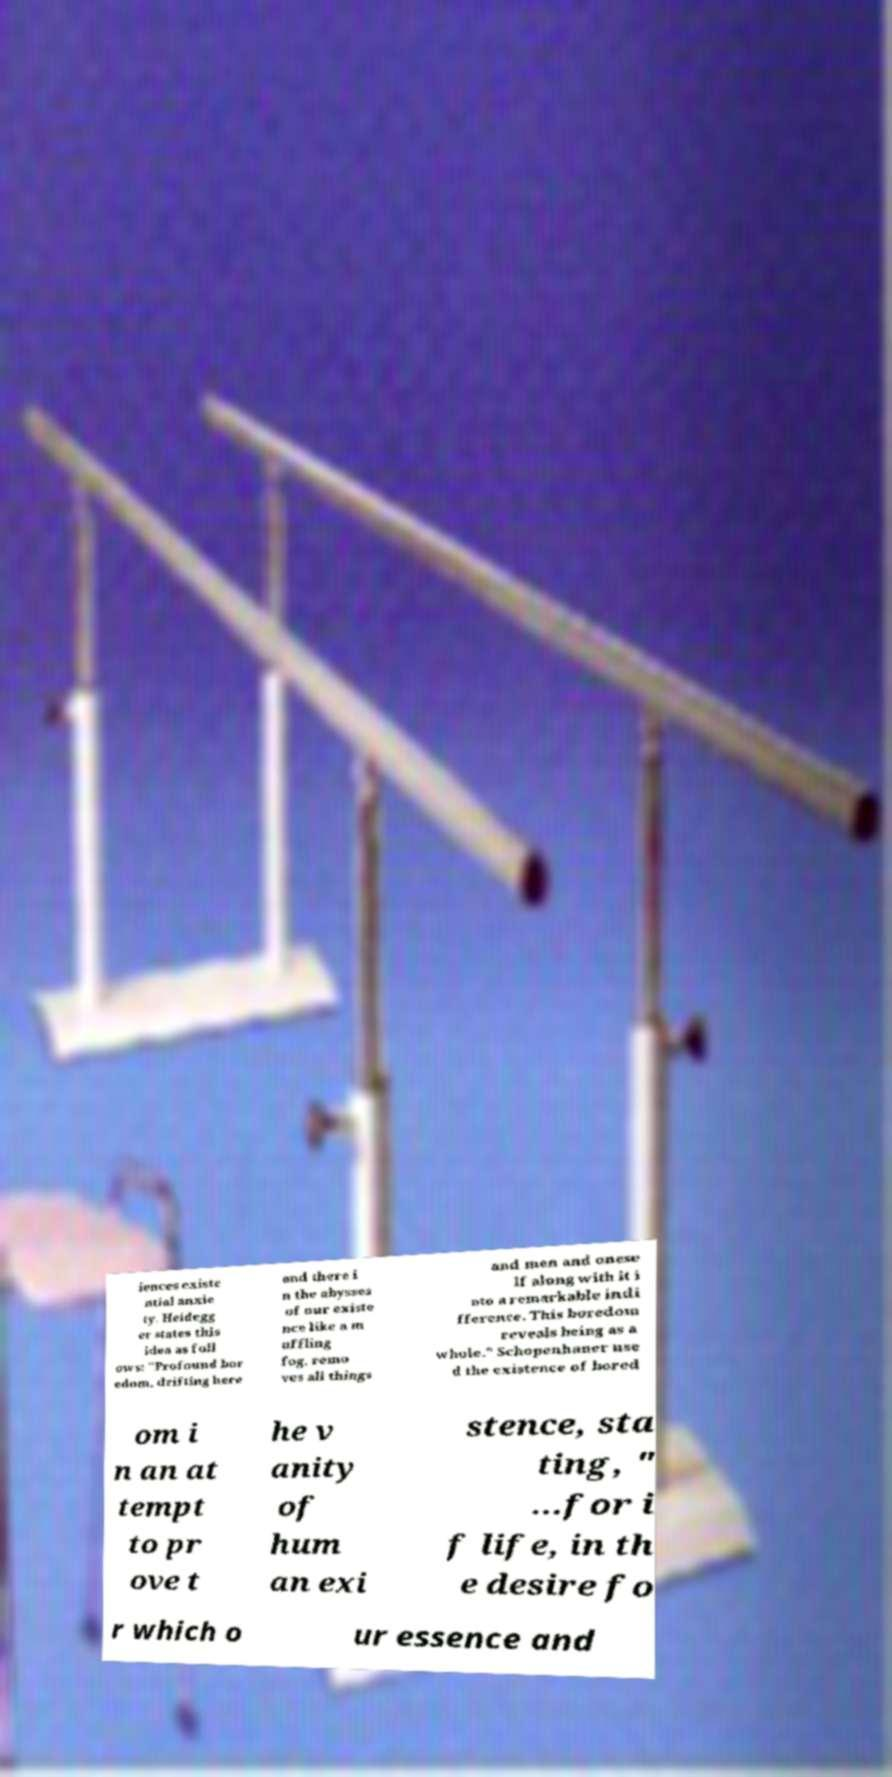Can you read and provide the text displayed in the image?This photo seems to have some interesting text. Can you extract and type it out for me? iences existe ntial anxie ty. Heidegg er states this idea as foll ows: "Profound bor edom, drifting here and there i n the abysses of our existe nce like a m uffling fog, remo ves all things and men and onese lf along with it i nto a remarkable indi fference. This boredom reveals being as a whole." Schopenhauer use d the existence of bored om i n an at tempt to pr ove t he v anity of hum an exi stence, sta ting, " ...for i f life, in th e desire fo r which o ur essence and 